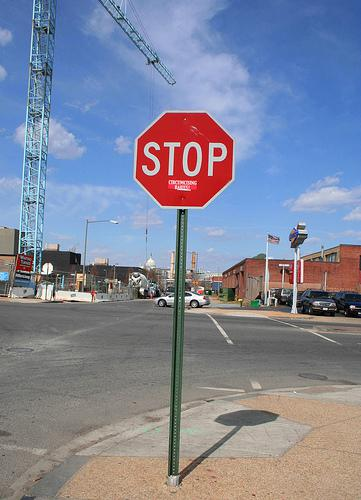Question: what has the sign cast?
Choices:
A. A shadow.
B. Sorrow for the town.
C. Shine.
D. Blurred vision for the drivers.
Answer with the letter. Answer: A Question: what shape is the sign?
Choices:
A. Square.
B. Circle.
C. Octagon.
D. Rectangle.
Answer with the letter. Answer: C Question: why is the sign red?
Choices:
A. He likes the color.
B. To be noticable.
C. For the firehouse.
D. To stop.
Answer with the letter. Answer: D Question: what kind of a car is behind the sign?
Choices:
A. Suv.
B. Truck.
C. Pickup.
D. Sedan.
Answer with the letter. Answer: D Question: where is the building?
Choices:
A. The right side.
B. In the middle.
C. At the end.
D. Down the street.
Answer with the letter. Answer: A 